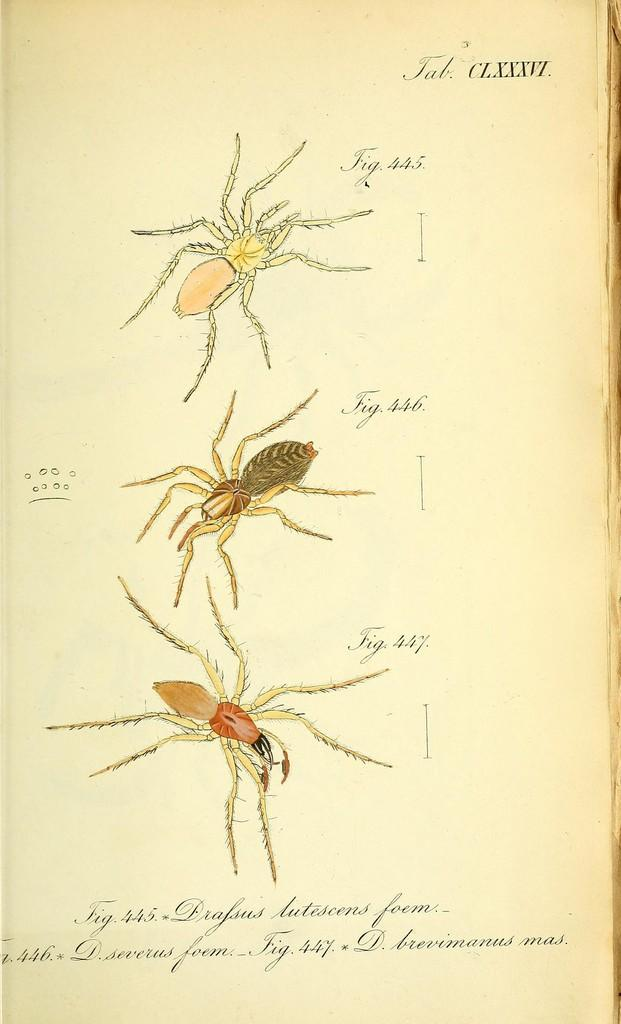What is the main subject of the image? The main subject of the image is different types of spider images. What else can be seen on the paper besides the spider images? There is text on the paper. Where can the shelf be seen in the image? There is no shelf present in the image; it only contains spider images and text on a paper. 